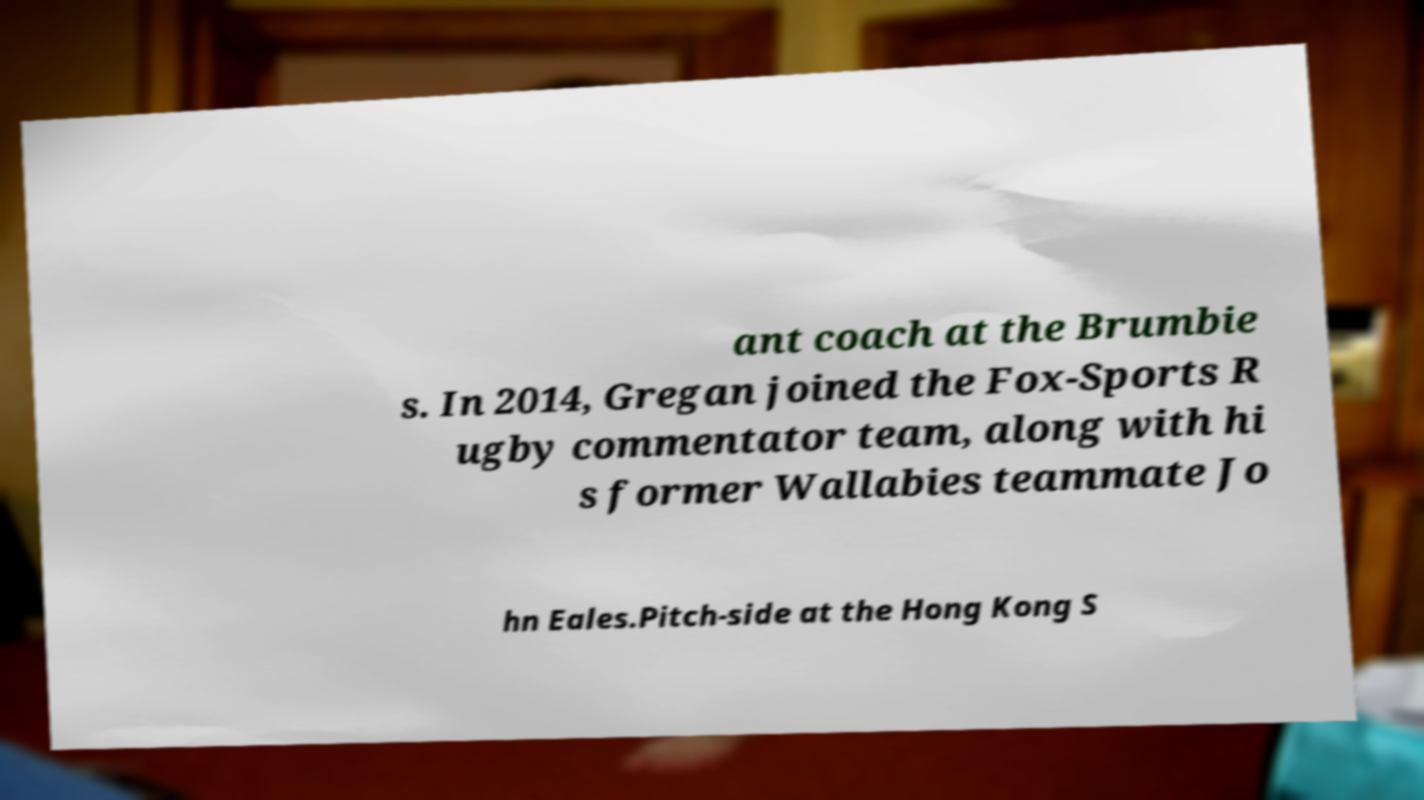For documentation purposes, I need the text within this image transcribed. Could you provide that? ant coach at the Brumbie s. In 2014, Gregan joined the Fox-Sports R ugby commentator team, along with hi s former Wallabies teammate Jo hn Eales.Pitch-side at the Hong Kong S 